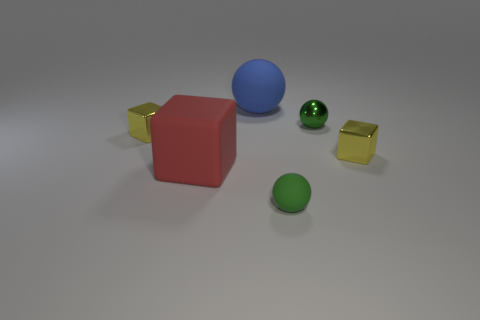Add 3 tiny green shiny objects. How many objects exist? 9 Subtract 0 blue blocks. How many objects are left? 6 Subtract all large cubes. Subtract all blue objects. How many objects are left? 4 Add 5 small objects. How many small objects are left? 9 Add 3 blocks. How many blocks exist? 6 